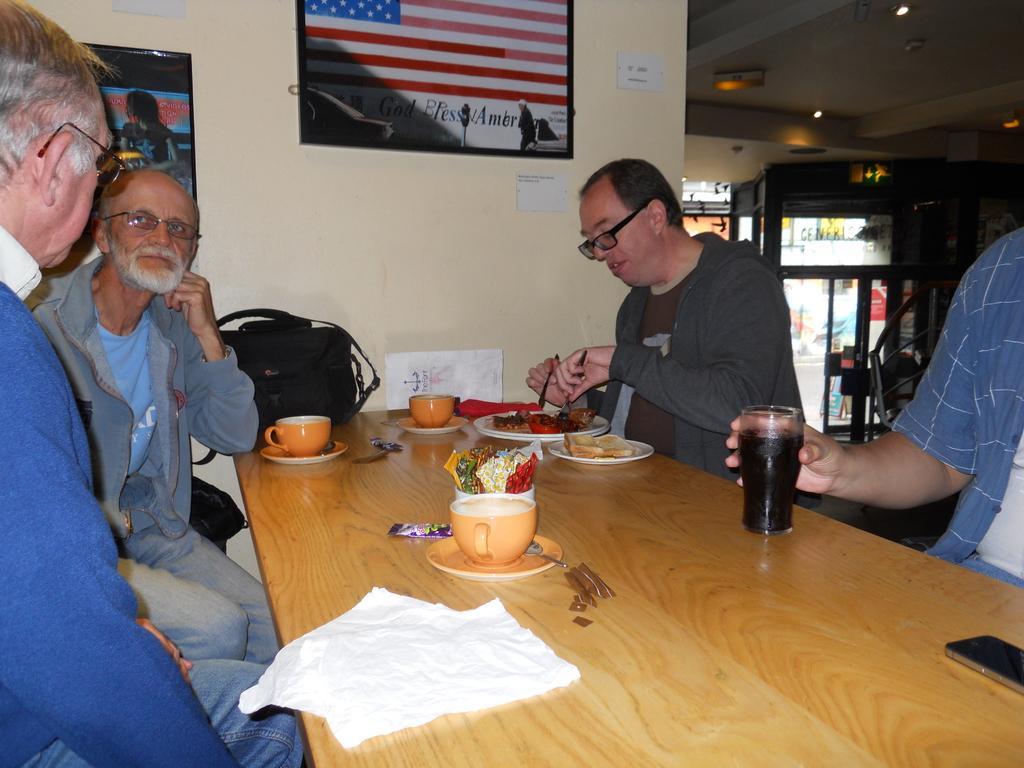How would you summarize this image in a sentence or two? There are four people sitting around a table. They are wearing specs. On the table there are cups, saucers, plates, glass and food items, also there is a bag and papers. In the background there is a wall with pictures. 